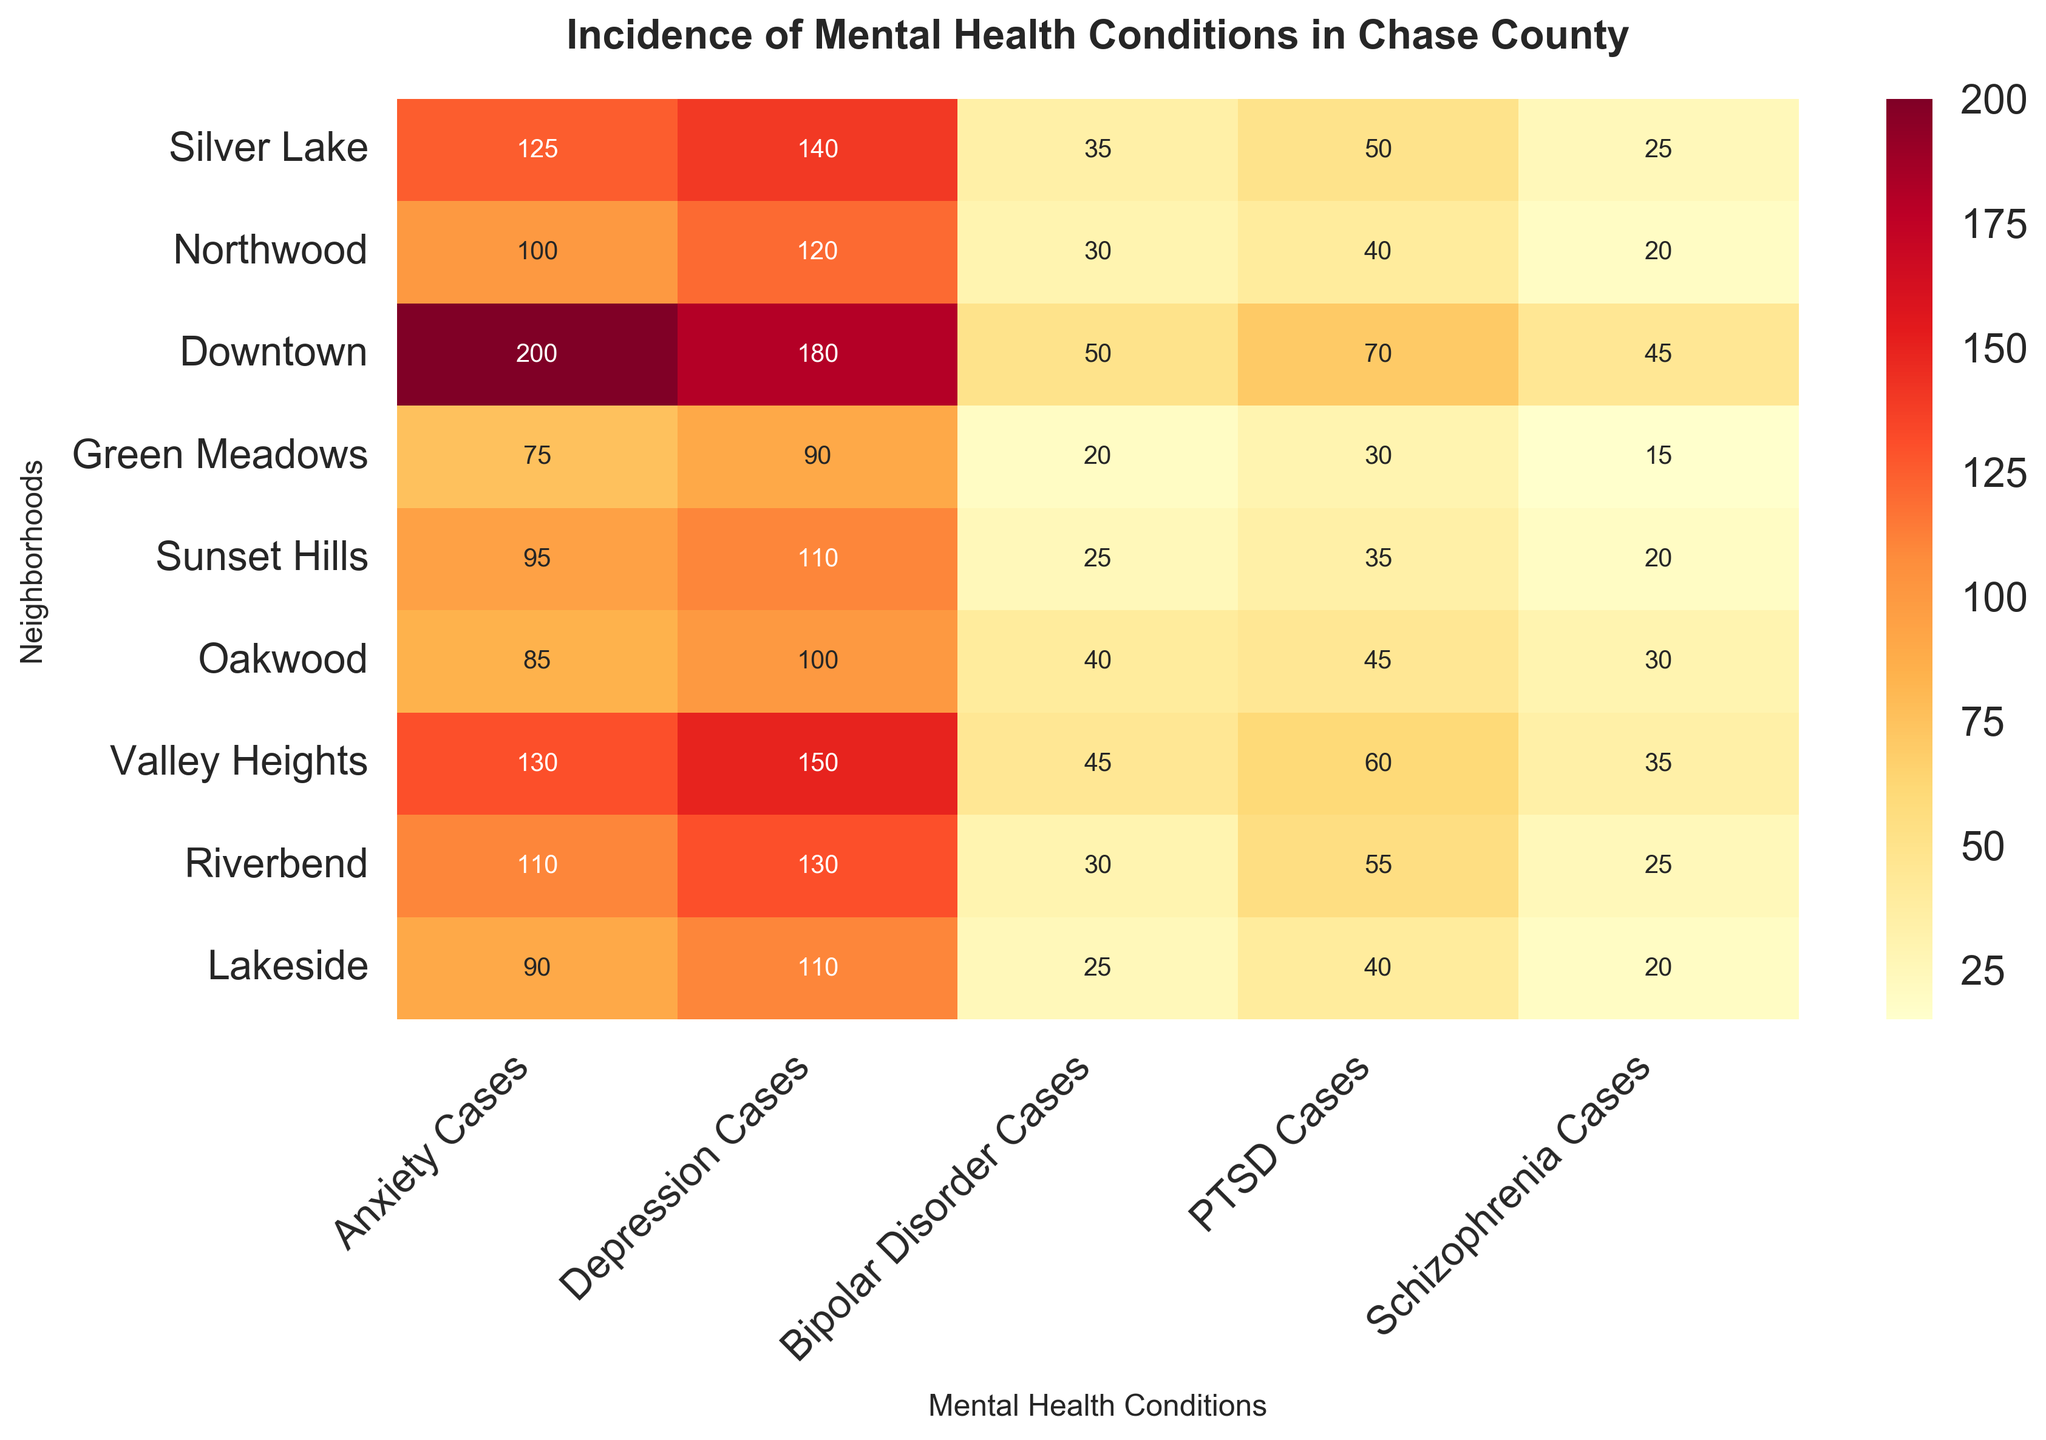How many cases of Bipolar Disorder are there in Downtown? Look at the Downtown row and the Bipolar Disorder column.
Answer: 50 Which neighborhood has the highest number of Anxiety cases? Compare the numbers in the Anxiety Cases column across all neighborhoods and identify the highest.
Answer: Downtown What is the total number of Depression cases in both Green Meadows and Oakwood? Add the Depression cases for Green Meadows (90) and Oakwood (100).
Answer: 190 Which neighborhood has a higher number of PTSD cases, Silver Lake or Riverbend? Compare PTSD cases in Silver Lake (50) and Riverbend (55).
Answer: Riverbend What is the average number of Schizophrenia cases across all neighborhoods? Sum the Schizophrenia cases for all neighborhoods and divide by the number of neighborhoods (9). Calculation: (25+20+45+15+20+30+35+25+20)/9 = 235/9 ≈ 26.11
Answer: 26.11 Which mental health condition has the lowest incidence in Valley Heights? Compare the values in Valley Heights row and identify the lowest.
Answer: Schizophrenia Is the number of Anxiety cases in Lakeside greater than the number of Depression cases in Sunset Hills? Compare Anxiety cases in Lakeside (90) with Depression cases in Sunset Hills (110).
Answer: No What is the range (difference between highest and lowest) of PTSD cases across all neighborhoods? Identify the highest (Downtown, 70) and lowest (Green Meadows, 30) values in the PTSD Cases column and subtract the lowest from the highest.
Answer: 40 Which neighborhood has the second highest number of Anxiety cases? List the Anxiety cases and determine the second highest value (Silver Lake, 125).
Answer: Silver Lake What is the total number of cases across all conditions in Northwood? Sum all cases for Northwood: 100 + 120 + 30 + 40 + 20 = 310.
Answer: 310 